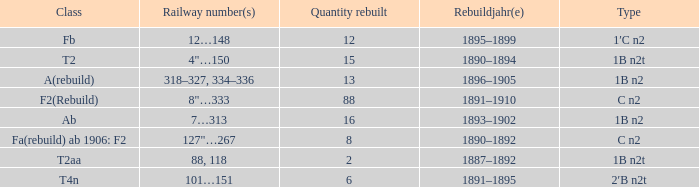What is the total of quantity rebuilt if the type is 1B N2T and the railway number is 88, 118? 1.0. 